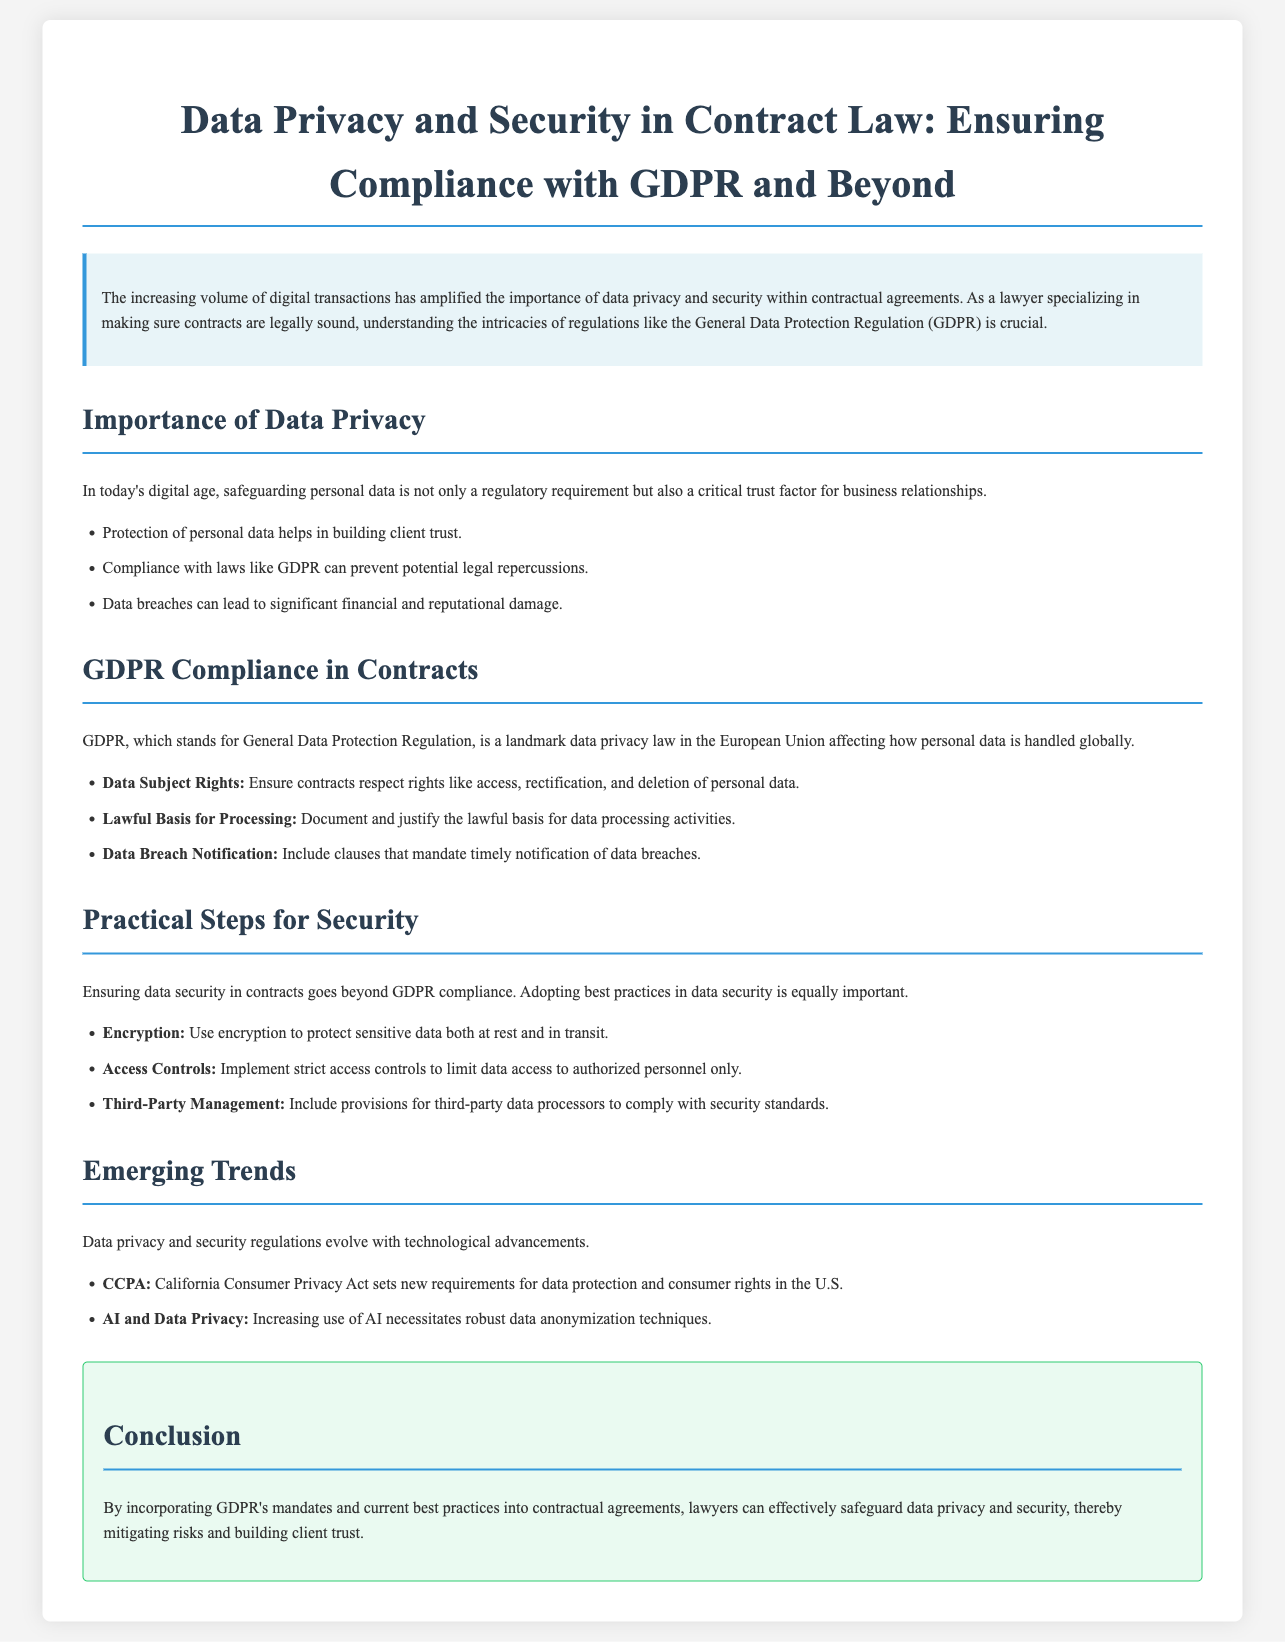What is the main purpose of the document? The main purpose is to discuss data privacy and security in contract law while ensuring compliance with GDPR and other regulations.
Answer: Discuss data privacy and security in contract law What are the regulations mentioned in the document? The document mentions GDPR and CCPA as key regulations in data privacy.
Answer: GDPR and CCPA What is one of the Data Subject Rights under GDPR? The document states that contracts must respect the rights like access, rectification, and deletion of personal data.
Answer: Access What protection measure is recommended for sensitive data? The document highlights the importance of using encryption to protect sensitive data both at rest and in transit.
Answer: Encryption What does CCPA stand for? The document specifically states that CCPA refers to the California Consumer Privacy Act.
Answer: California Consumer Privacy Act What is a lawful basis for processing data? It refers to the requirement to document and justify the lawful basis for data processing activities as indicated in the document.
Answer: Document and justify What type of technology is increasing the need for robust data anonymization techniques? The document mentions that the increasing use of AI necessitates robust data anonymization techniques.
Answer: AI What is the conclusion of the document? The conclusion emphasizes the incorporation of GDPR's mandates and best practices into contractual agreements to safeguard data privacy and security.
Answer: Incorporate GDPR's mandates and best practices What element is crucial for building client trust according to the document? Safeguarding personal data serves as a critical trust factor for business relationships.
Answer: Safeguarding personal data 